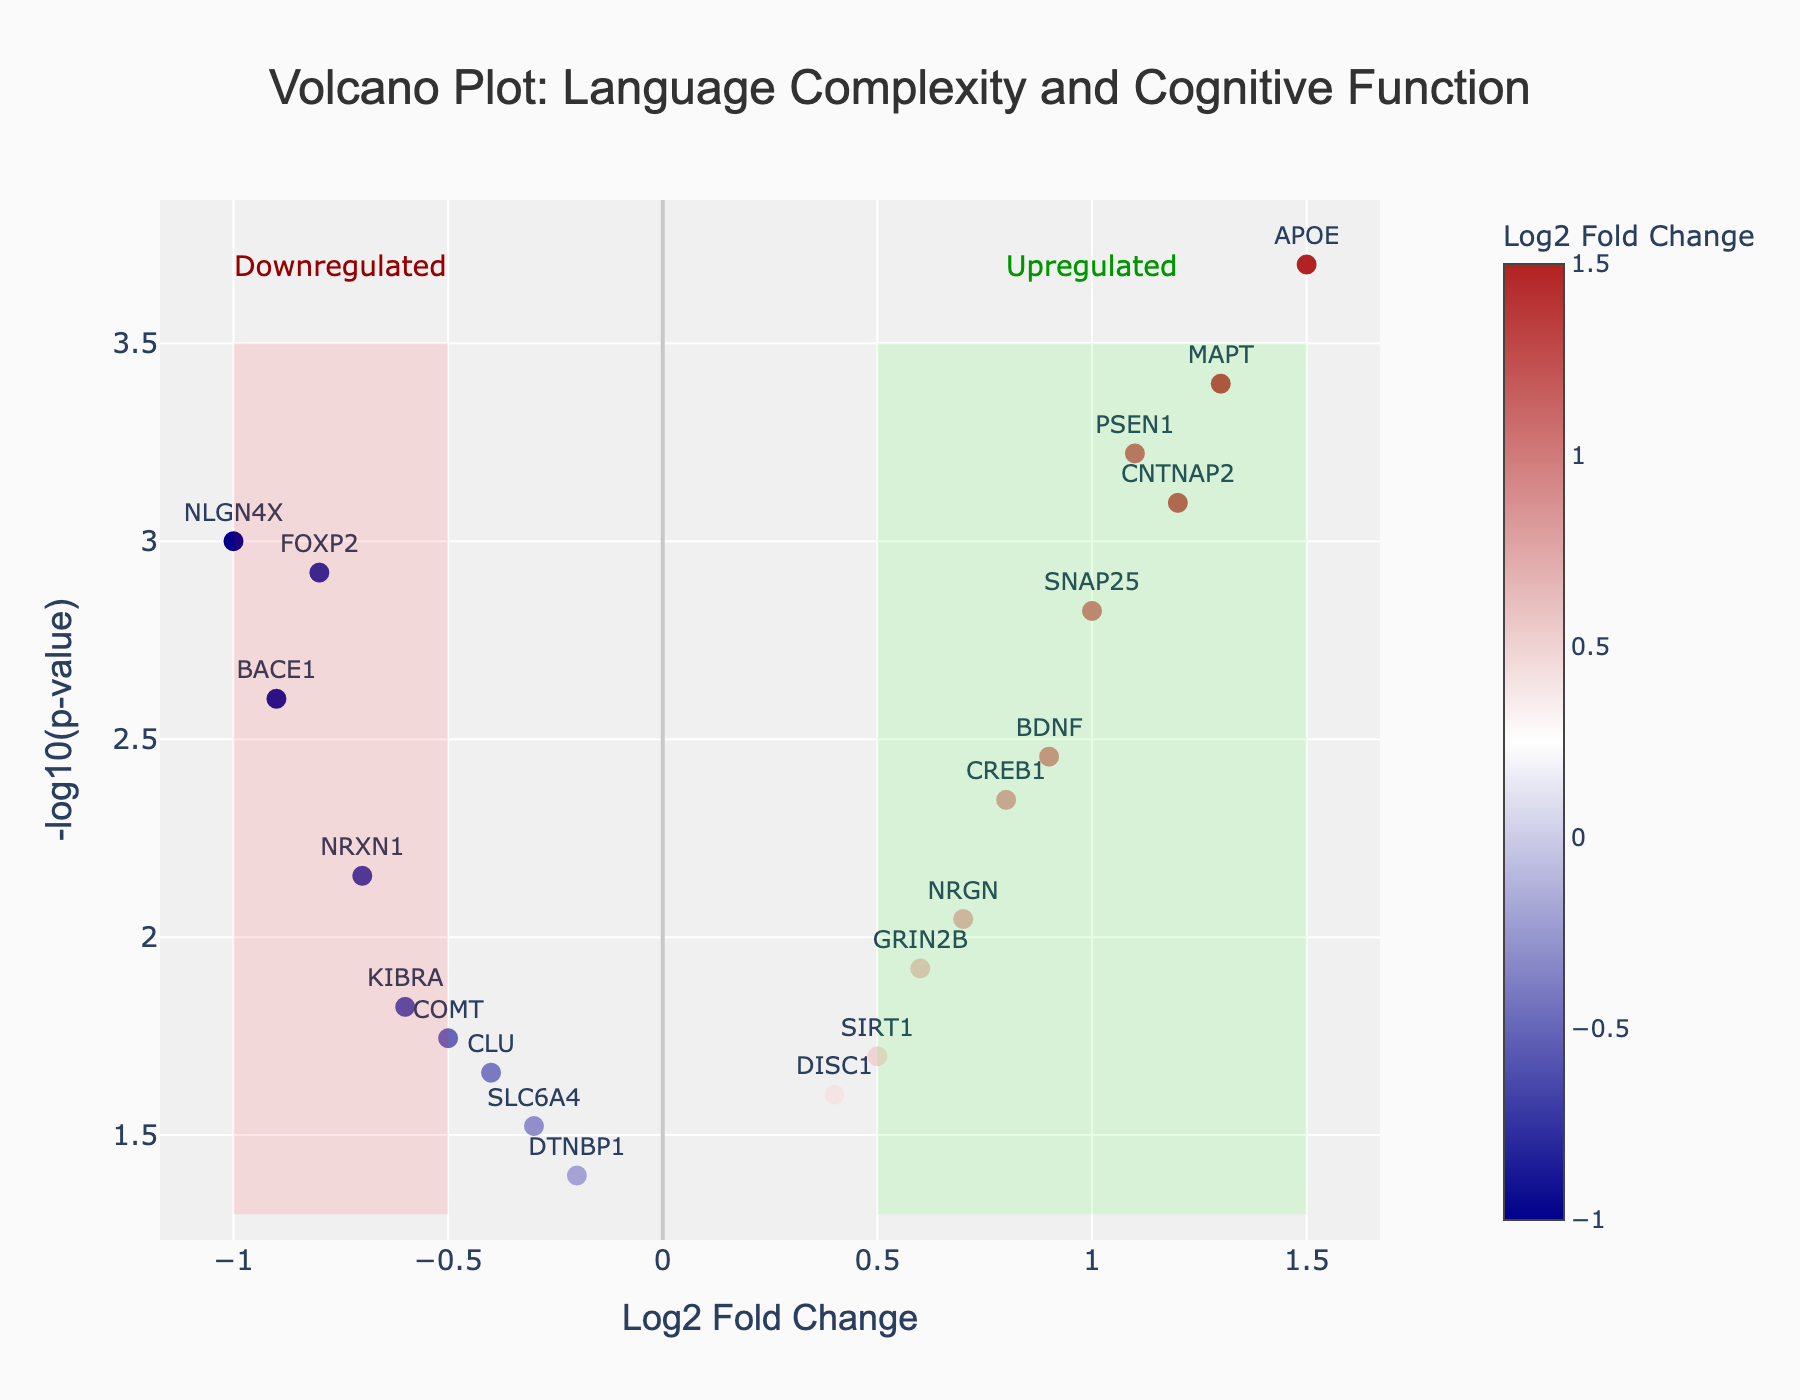What's the title of the volcano plot? The title is usually located at the top center of the plot. Here, it states that the plot is about the correlation between language complexity and cognitive function.
Answer: Volcano Plot: Language Complexity and Cognitive Function What do the x-axis and y-axis represent in this plot? The x-axis shows the Log2 Fold Change, indicating the change in gene expression levels. The y-axis displays the -log10(p-value), representing the significance of the changes.
Answer: Log2 Fold Change and -log10(p-value) How many genes are upregulated, according to the plot? Upregulated genes have positive log2 fold changes (x-axis values greater than 0). By counting these, we get: CNTNAP2, BDNF, APOE, PSEN1, CREB1, SNAP25, GRIN2B, MAPT, SIRT1, DISC1, which total to 10 genes.
Answer: 10 Which gene has the most significant downregulation? Significance is indicated by a higher -log10(p-value), and downregulation by a negative log2 fold change. NLGN4X has the highest significance with a high -log10(p-value) and a negative fold change.
Answer: NLGN4X Compare the log2 fold change of FOXP2 and CNTNAP2. Which one is larger and by how much? FOXP2 has a log2 fold change of -0.8, and CNTNAP2 has 1.2. The difference is 1.2 - (-0.8) = 2.0. Therefore, CNTNAP2 is larger by 2.0.
Answer: CNTNAP2 by 2.0 What area of the plot represents highly significant genes with substantial upregulation? Highly significant genes appear at the top of the plot, and substantial upregulation is on the right side (positive log2 fold change). The highlighted “Upregulated” area shows this region.
Answer: Top-right corner Which gene has the smallest p-value, indicating the highest significance? A smaller p-value means a higher -log10(p-value). APOE has a log2 fold change of 1.5 and the highest y-axis value, indicating the smallest p-value.
Answer: APOE How many genes have a log2 fold change less than -0.5? Genes with log2 fold changes less than -0.5 include FOXP2, KIBRA, NRXN1, BACE1, NLGN4X. Counting these: there are 5 genes.
Answer: 5 What is the log2 fold change and -log10(p-value) for SNAP25? For SNAP25, the log2 fold change is 1.0, and the -log10(p-value) can be found directly on the plot by its y-value. Since it’s highly significant, -log10(p-value) is around 2.8.
Answer: 1.0 and ~2.8 Which gene is close to the origin (log2 fold change around 0 and low significance)? The origin indicates almost no change in expression and low significance. DTNBP1, with a log2 fold change of -0.2 and a relatively low -log10(p-value), is close to this.
Answer: DTNBP1 